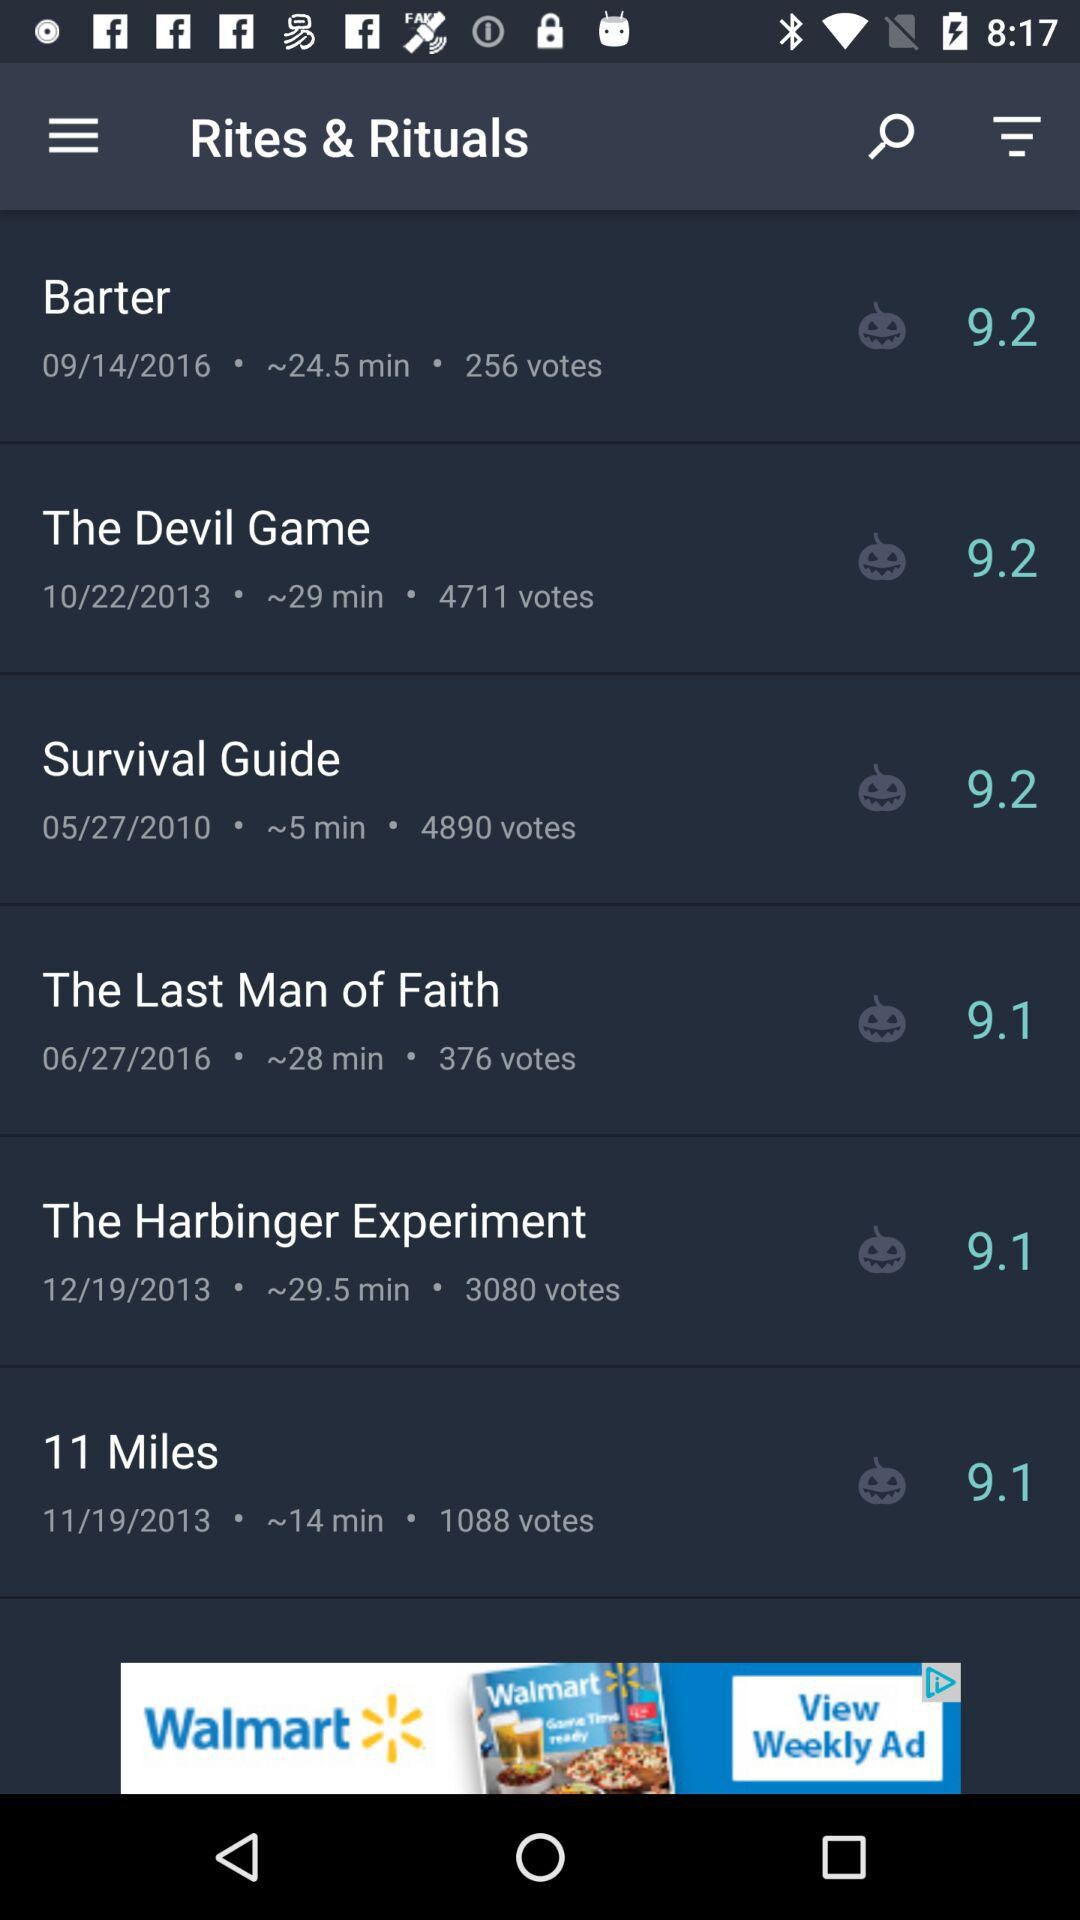What is the date shown for "The Devil Game"? The date is "10/22/2013". 